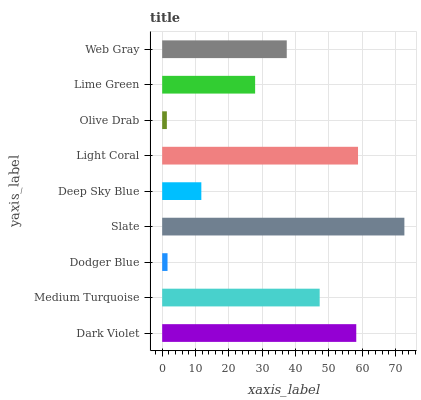Is Olive Drab the minimum?
Answer yes or no. Yes. Is Slate the maximum?
Answer yes or no. Yes. Is Medium Turquoise the minimum?
Answer yes or no. No. Is Medium Turquoise the maximum?
Answer yes or no. No. Is Dark Violet greater than Medium Turquoise?
Answer yes or no. Yes. Is Medium Turquoise less than Dark Violet?
Answer yes or no. Yes. Is Medium Turquoise greater than Dark Violet?
Answer yes or no. No. Is Dark Violet less than Medium Turquoise?
Answer yes or no. No. Is Web Gray the high median?
Answer yes or no. Yes. Is Web Gray the low median?
Answer yes or no. Yes. Is Light Coral the high median?
Answer yes or no. No. Is Light Coral the low median?
Answer yes or no. No. 